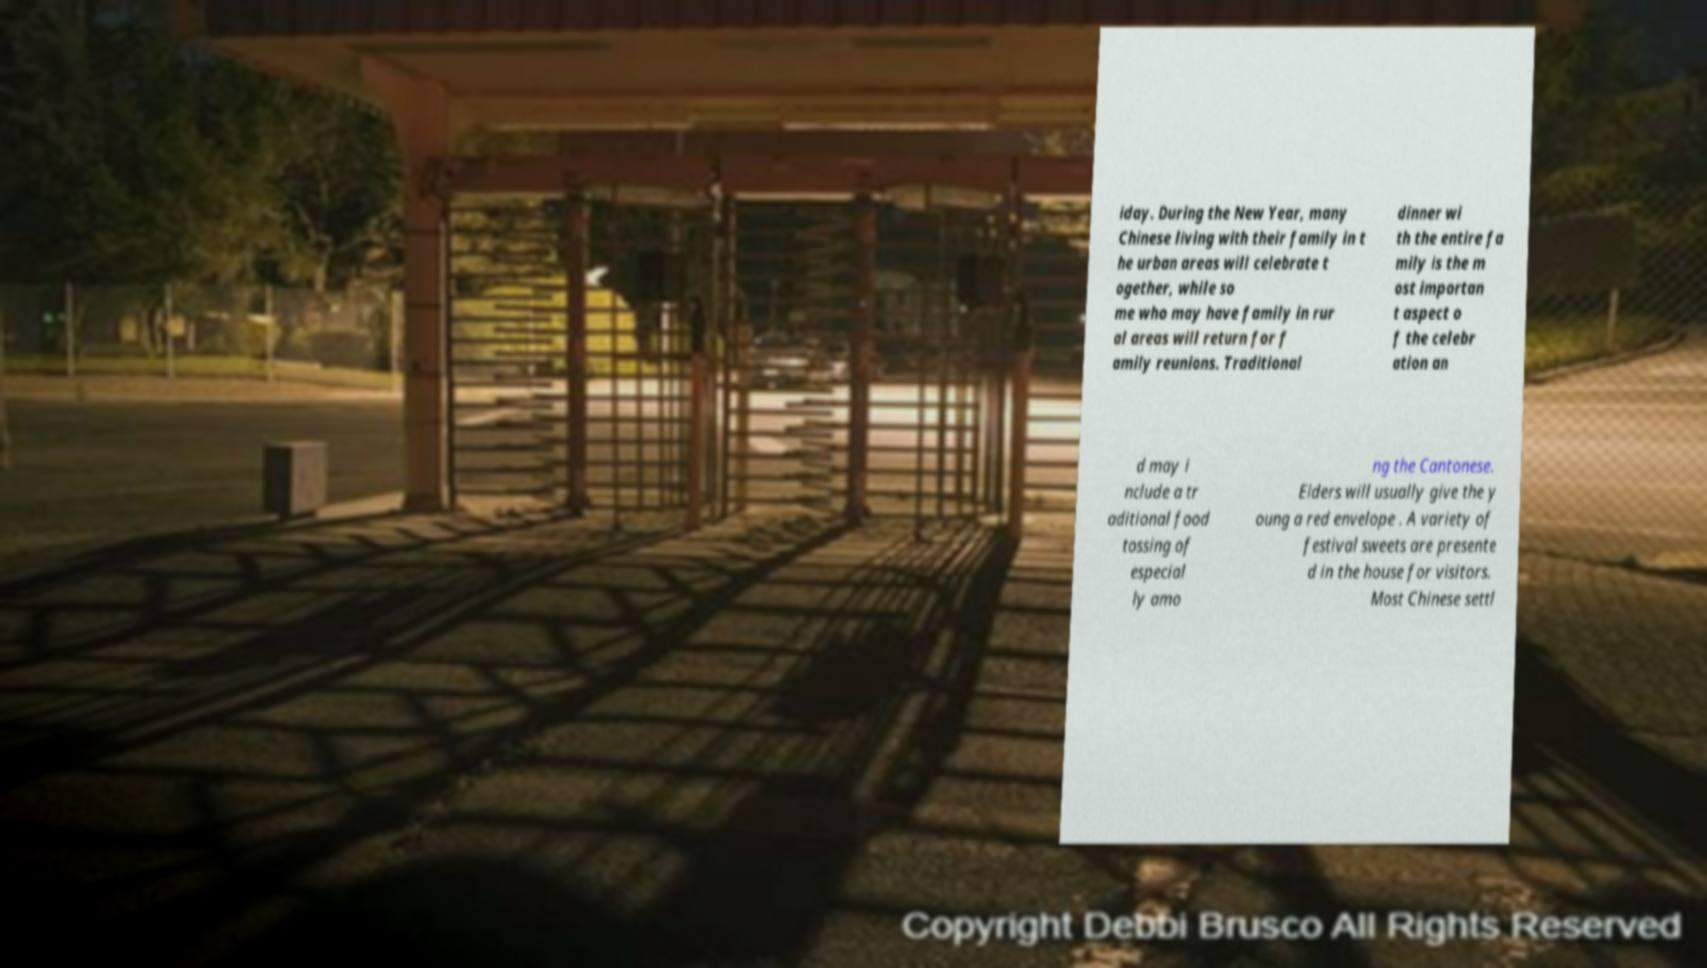Please read and relay the text visible in this image. What does it say? iday. During the New Year, many Chinese living with their family in t he urban areas will celebrate t ogether, while so me who may have family in rur al areas will return for f amily reunions. Traditional dinner wi th the entire fa mily is the m ost importan t aspect o f the celebr ation an d may i nclude a tr aditional food tossing of especial ly amo ng the Cantonese. Elders will usually give the y oung a red envelope . A variety of festival sweets are presente d in the house for visitors. Most Chinese settl 